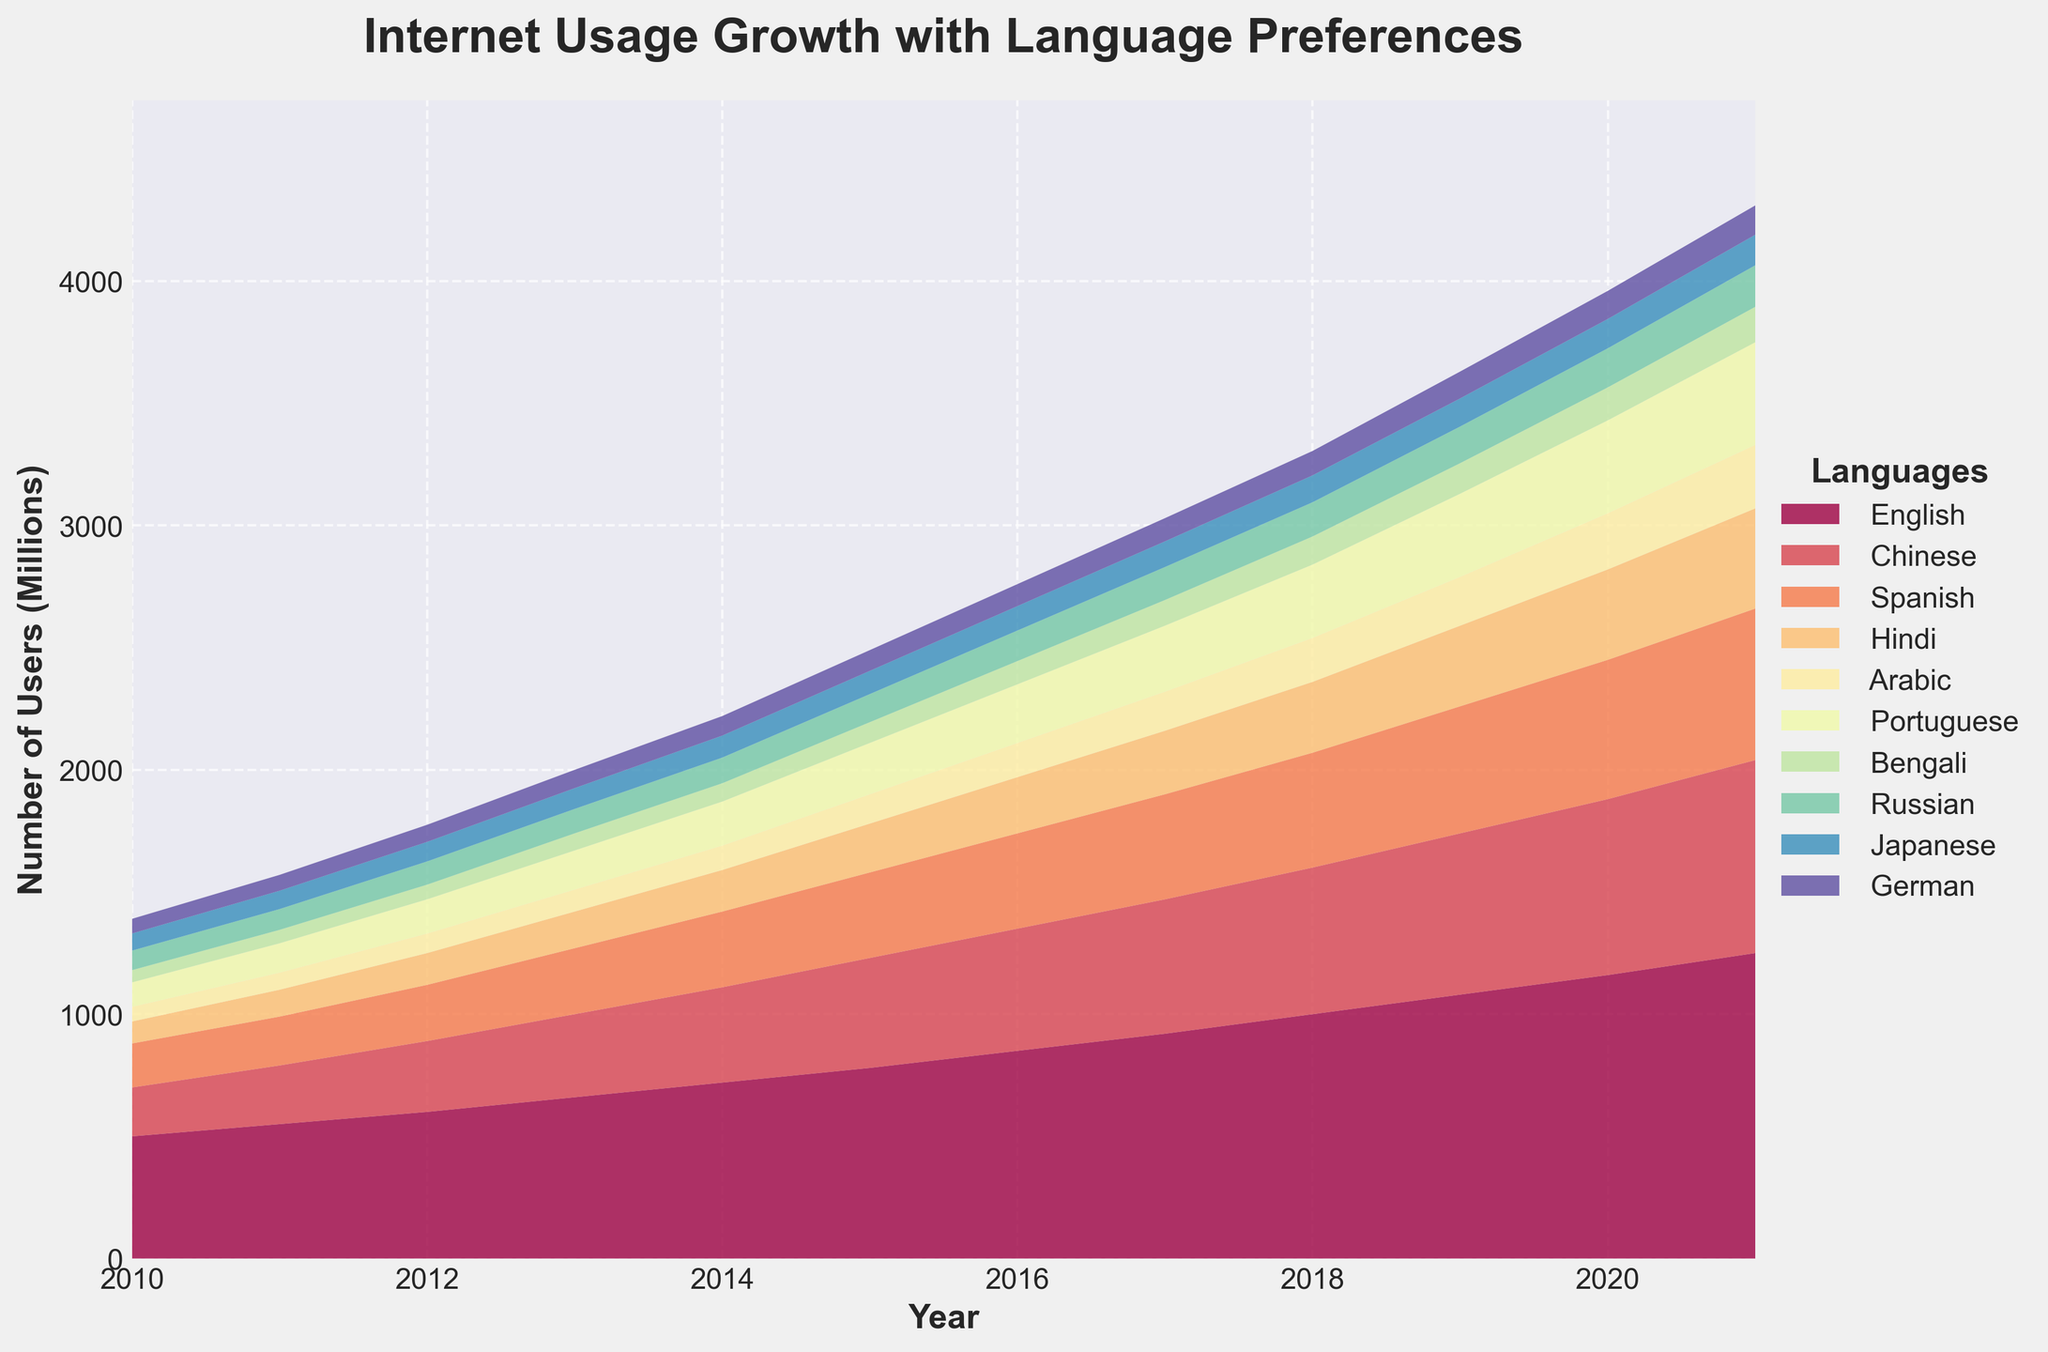What is the title of the figure? The title of the figure is typically displayed at the top, and in this case, it is given as 'Internet Usage Growth with Language Preferences'.
Answer: 'Internet Usage Growth with Language Preferences' What is the range of years displayed on the x-axis? The x-axis shows the years from 2010 to 2021 based on the given data.
Answer: 2010 to 2021 Which language has the most users in 2021? By looking at the stacked areas, the language at the top layer in 2021 represents the maximum user count. The English layer is the topmost, indicating the highest number of users.
Answer: English How many languages are represented in the figure? The legend on the right-hand side lists all languages, which can be counted to determine the number. There are 10 languages shown based on the legend.
Answer: 10 Which two languages saw the most significant growth from 2010 to 2021? Observing the areas' heights over the years, English and Chinese show the most substantial vertical growth from 2010 to 2021.
Answer: English and Chinese What is the number of users for Chinese in 2015? The height of the Chinese area can be referenced against the y-axis in 2015. Approximately it sits around 450 million.
Answer: 450 million Compare the number of users for Spanish and Hindi in 2020. Which one has more users? By stacking the adjacent colors for Spanish and Hindi in 2020, Spanish (dark blue) is larger than Hindi (lighter blue), indicating more users.
Answer: Spanish What is the approximate total number of users in 2021? Adding up the maximums of all the stacked areas for 2021, the sum approximately totals near 1250 (English) + 790 (Chinese) + others. It hints at being more than 4500 million.
Answer: Around 4990 million Which language had the least increase in users between 2010 and 2021? The size difference of the colored sections helps identify the least growth. Bengali appears to have minimal growth when comparing the area size over time.
Answer: Bengali Which years had the fastest ascending slopes for Hindi users? The slope/steep rise of the light blue area for Hindi can show the fastest growth years. Between 2012-2013 and 2014-2015, steep growth is visible.
Answer: 2012-2013 and 2014-2015 